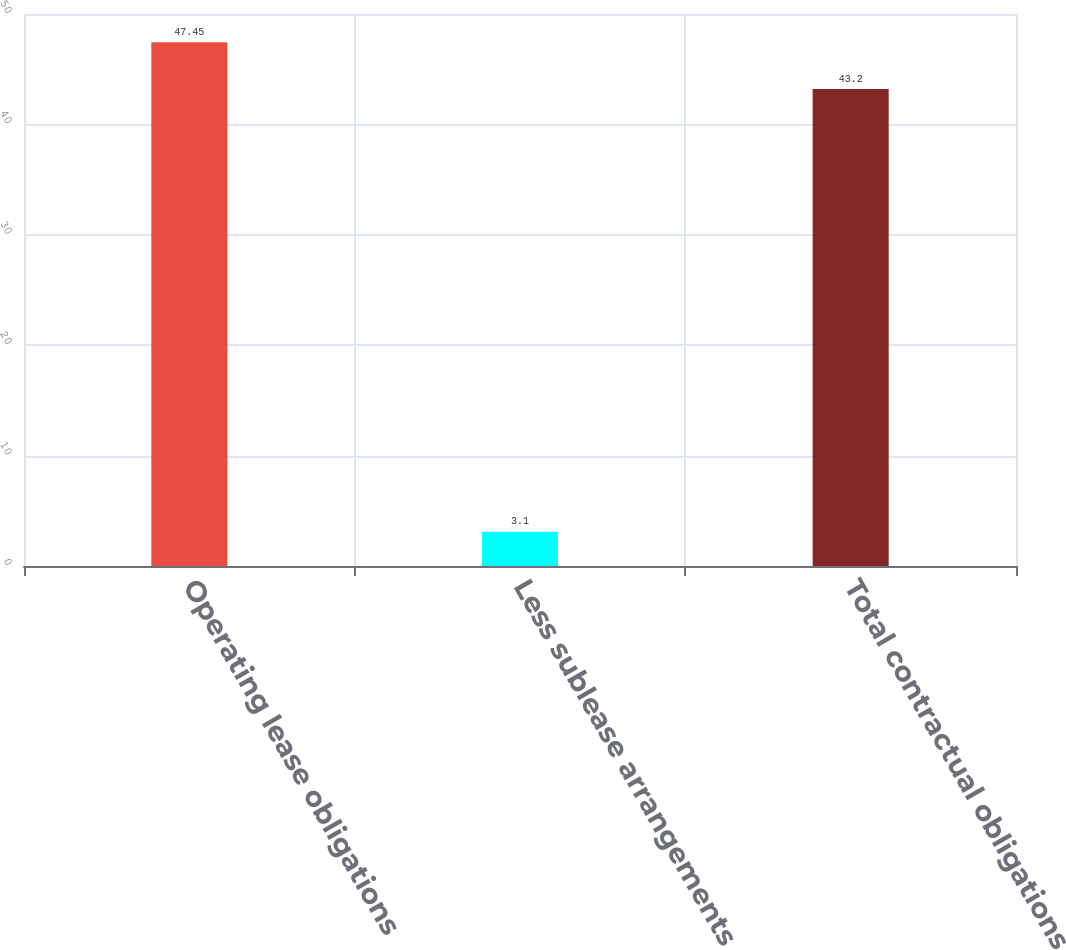<chart> <loc_0><loc_0><loc_500><loc_500><bar_chart><fcel>Operating lease obligations<fcel>Less sublease arrangements<fcel>Total contractual obligations<nl><fcel>47.45<fcel>3.1<fcel>43.2<nl></chart> 